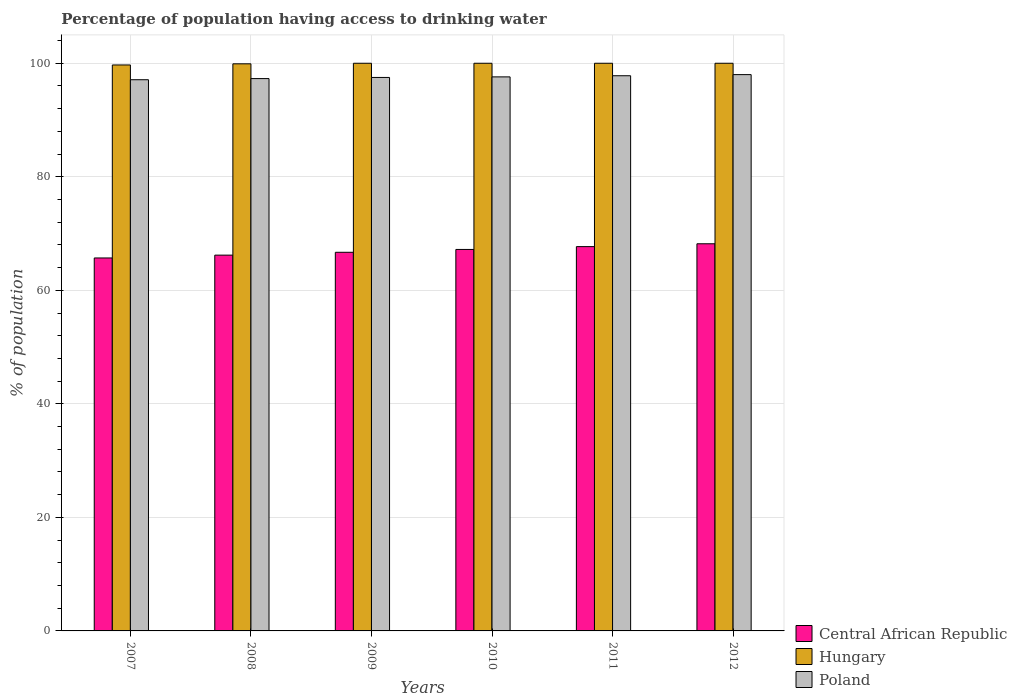How many bars are there on the 6th tick from the right?
Provide a short and direct response. 3. What is the label of the 4th group of bars from the left?
Give a very brief answer. 2010. In how many cases, is the number of bars for a given year not equal to the number of legend labels?
Ensure brevity in your answer.  0. What is the percentage of population having access to drinking water in Hungary in 2007?
Your answer should be very brief. 99.7. Across all years, what is the maximum percentage of population having access to drinking water in Central African Republic?
Provide a succinct answer. 68.2. Across all years, what is the minimum percentage of population having access to drinking water in Poland?
Ensure brevity in your answer.  97.1. In which year was the percentage of population having access to drinking water in Central African Republic maximum?
Provide a short and direct response. 2012. What is the total percentage of population having access to drinking water in Hungary in the graph?
Your answer should be very brief. 599.6. What is the difference between the percentage of population having access to drinking water in Central African Republic in 2010 and that in 2012?
Your answer should be compact. -1. What is the difference between the percentage of population having access to drinking water in Hungary in 2011 and the percentage of population having access to drinking water in Central African Republic in 2010?
Provide a short and direct response. 32.8. What is the average percentage of population having access to drinking water in Poland per year?
Your answer should be compact. 97.55. In the year 2008, what is the difference between the percentage of population having access to drinking water in Hungary and percentage of population having access to drinking water in Central African Republic?
Offer a terse response. 33.7. In how many years, is the percentage of population having access to drinking water in Poland greater than 64 %?
Provide a short and direct response. 6. What is the ratio of the percentage of population having access to drinking water in Poland in 2010 to that in 2011?
Offer a very short reply. 1. Is the percentage of population having access to drinking water in Central African Republic in 2007 less than that in 2010?
Provide a succinct answer. Yes. What is the difference between the highest and the second highest percentage of population having access to drinking water in Central African Republic?
Provide a succinct answer. 0.5. What is the difference between the highest and the lowest percentage of population having access to drinking water in Poland?
Your response must be concise. 0.9. Is the sum of the percentage of population having access to drinking water in Poland in 2008 and 2009 greater than the maximum percentage of population having access to drinking water in Hungary across all years?
Make the answer very short. Yes. What does the 3rd bar from the left in 2010 represents?
Provide a succinct answer. Poland. Is it the case that in every year, the sum of the percentage of population having access to drinking water in Hungary and percentage of population having access to drinking water in Poland is greater than the percentage of population having access to drinking water in Central African Republic?
Your answer should be compact. Yes. How many bars are there?
Provide a succinct answer. 18. How many years are there in the graph?
Your response must be concise. 6. Are the values on the major ticks of Y-axis written in scientific E-notation?
Provide a succinct answer. No. What is the title of the graph?
Provide a short and direct response. Percentage of population having access to drinking water. Does "Other small states" appear as one of the legend labels in the graph?
Your response must be concise. No. What is the label or title of the Y-axis?
Ensure brevity in your answer.  % of population. What is the % of population of Central African Republic in 2007?
Provide a succinct answer. 65.7. What is the % of population of Hungary in 2007?
Your answer should be compact. 99.7. What is the % of population in Poland in 2007?
Offer a very short reply. 97.1. What is the % of population of Central African Republic in 2008?
Your answer should be very brief. 66.2. What is the % of population of Hungary in 2008?
Provide a short and direct response. 99.9. What is the % of population of Poland in 2008?
Your answer should be compact. 97.3. What is the % of population of Central African Republic in 2009?
Keep it short and to the point. 66.7. What is the % of population in Hungary in 2009?
Provide a succinct answer. 100. What is the % of population in Poland in 2009?
Your response must be concise. 97.5. What is the % of population in Central African Republic in 2010?
Your answer should be compact. 67.2. What is the % of population in Poland in 2010?
Provide a short and direct response. 97.6. What is the % of population in Central African Republic in 2011?
Give a very brief answer. 67.7. What is the % of population in Poland in 2011?
Offer a very short reply. 97.8. What is the % of population of Central African Republic in 2012?
Ensure brevity in your answer.  68.2. What is the % of population in Hungary in 2012?
Your answer should be compact. 100. What is the % of population of Poland in 2012?
Keep it short and to the point. 98. Across all years, what is the maximum % of population in Central African Republic?
Make the answer very short. 68.2. Across all years, what is the maximum % of population in Poland?
Your answer should be very brief. 98. Across all years, what is the minimum % of population of Central African Republic?
Make the answer very short. 65.7. Across all years, what is the minimum % of population in Hungary?
Make the answer very short. 99.7. Across all years, what is the minimum % of population in Poland?
Offer a very short reply. 97.1. What is the total % of population of Central African Republic in the graph?
Provide a short and direct response. 401.7. What is the total % of population of Hungary in the graph?
Provide a short and direct response. 599.6. What is the total % of population of Poland in the graph?
Your response must be concise. 585.3. What is the difference between the % of population in Central African Republic in 2007 and that in 2008?
Provide a succinct answer. -0.5. What is the difference between the % of population of Central African Republic in 2007 and that in 2009?
Keep it short and to the point. -1. What is the difference between the % of population of Hungary in 2007 and that in 2009?
Provide a succinct answer. -0.3. What is the difference between the % of population of Poland in 2007 and that in 2010?
Your response must be concise. -0.5. What is the difference between the % of population of Hungary in 2007 and that in 2011?
Provide a short and direct response. -0.3. What is the difference between the % of population of Poland in 2007 and that in 2011?
Your answer should be very brief. -0.7. What is the difference between the % of population in Central African Republic in 2007 and that in 2012?
Your answer should be compact. -2.5. What is the difference between the % of population in Hungary in 2007 and that in 2012?
Make the answer very short. -0.3. What is the difference between the % of population of Hungary in 2008 and that in 2009?
Make the answer very short. -0.1. What is the difference between the % of population of Poland in 2008 and that in 2010?
Give a very brief answer. -0.3. What is the difference between the % of population of Central African Republic in 2008 and that in 2011?
Your answer should be compact. -1.5. What is the difference between the % of population of Central African Republic in 2009 and that in 2010?
Provide a short and direct response. -0.5. What is the difference between the % of population in Hungary in 2009 and that in 2010?
Make the answer very short. 0. What is the difference between the % of population in Poland in 2009 and that in 2010?
Ensure brevity in your answer.  -0.1. What is the difference between the % of population in Central African Republic in 2009 and that in 2011?
Make the answer very short. -1. What is the difference between the % of population of Hungary in 2009 and that in 2012?
Give a very brief answer. 0. What is the difference between the % of population of Central African Republic in 2010 and that in 2011?
Your answer should be very brief. -0.5. What is the difference between the % of population of Hungary in 2010 and that in 2011?
Ensure brevity in your answer.  0. What is the difference between the % of population of Poland in 2010 and that in 2011?
Offer a terse response. -0.2. What is the difference between the % of population of Central African Republic in 2010 and that in 2012?
Your answer should be very brief. -1. What is the difference between the % of population of Poland in 2010 and that in 2012?
Provide a succinct answer. -0.4. What is the difference between the % of population of Poland in 2011 and that in 2012?
Offer a terse response. -0.2. What is the difference between the % of population of Central African Republic in 2007 and the % of population of Hungary in 2008?
Offer a terse response. -34.2. What is the difference between the % of population of Central African Republic in 2007 and the % of population of Poland in 2008?
Keep it short and to the point. -31.6. What is the difference between the % of population in Central African Republic in 2007 and the % of population in Hungary in 2009?
Your answer should be compact. -34.3. What is the difference between the % of population in Central African Republic in 2007 and the % of population in Poland in 2009?
Provide a short and direct response. -31.8. What is the difference between the % of population in Hungary in 2007 and the % of population in Poland in 2009?
Your answer should be very brief. 2.2. What is the difference between the % of population in Central African Republic in 2007 and the % of population in Hungary in 2010?
Offer a terse response. -34.3. What is the difference between the % of population of Central African Republic in 2007 and the % of population of Poland in 2010?
Make the answer very short. -31.9. What is the difference between the % of population in Hungary in 2007 and the % of population in Poland in 2010?
Ensure brevity in your answer.  2.1. What is the difference between the % of population in Central African Republic in 2007 and the % of population in Hungary in 2011?
Provide a succinct answer. -34.3. What is the difference between the % of population of Central African Republic in 2007 and the % of population of Poland in 2011?
Your answer should be compact. -32.1. What is the difference between the % of population in Hungary in 2007 and the % of population in Poland in 2011?
Make the answer very short. 1.9. What is the difference between the % of population of Central African Republic in 2007 and the % of population of Hungary in 2012?
Give a very brief answer. -34.3. What is the difference between the % of population of Central African Republic in 2007 and the % of population of Poland in 2012?
Your response must be concise. -32.3. What is the difference between the % of population of Central African Republic in 2008 and the % of population of Hungary in 2009?
Your response must be concise. -33.8. What is the difference between the % of population in Central African Republic in 2008 and the % of population in Poland in 2009?
Your answer should be very brief. -31.3. What is the difference between the % of population of Hungary in 2008 and the % of population of Poland in 2009?
Your answer should be very brief. 2.4. What is the difference between the % of population in Central African Republic in 2008 and the % of population in Hungary in 2010?
Your response must be concise. -33.8. What is the difference between the % of population of Central African Republic in 2008 and the % of population of Poland in 2010?
Provide a short and direct response. -31.4. What is the difference between the % of population in Central African Republic in 2008 and the % of population in Hungary in 2011?
Offer a terse response. -33.8. What is the difference between the % of population in Central African Republic in 2008 and the % of population in Poland in 2011?
Give a very brief answer. -31.6. What is the difference between the % of population of Hungary in 2008 and the % of population of Poland in 2011?
Give a very brief answer. 2.1. What is the difference between the % of population in Central African Republic in 2008 and the % of population in Hungary in 2012?
Your answer should be compact. -33.8. What is the difference between the % of population in Central African Republic in 2008 and the % of population in Poland in 2012?
Your answer should be compact. -31.8. What is the difference between the % of population in Hungary in 2008 and the % of population in Poland in 2012?
Ensure brevity in your answer.  1.9. What is the difference between the % of population in Central African Republic in 2009 and the % of population in Hungary in 2010?
Ensure brevity in your answer.  -33.3. What is the difference between the % of population in Central African Republic in 2009 and the % of population in Poland in 2010?
Give a very brief answer. -30.9. What is the difference between the % of population in Hungary in 2009 and the % of population in Poland in 2010?
Your answer should be very brief. 2.4. What is the difference between the % of population in Central African Republic in 2009 and the % of population in Hungary in 2011?
Offer a terse response. -33.3. What is the difference between the % of population of Central African Republic in 2009 and the % of population of Poland in 2011?
Your response must be concise. -31.1. What is the difference between the % of population of Central African Republic in 2009 and the % of population of Hungary in 2012?
Make the answer very short. -33.3. What is the difference between the % of population of Central African Republic in 2009 and the % of population of Poland in 2012?
Give a very brief answer. -31.3. What is the difference between the % of population in Hungary in 2009 and the % of population in Poland in 2012?
Your answer should be very brief. 2. What is the difference between the % of population in Central African Republic in 2010 and the % of population in Hungary in 2011?
Your answer should be compact. -32.8. What is the difference between the % of population of Central African Republic in 2010 and the % of population of Poland in 2011?
Provide a short and direct response. -30.6. What is the difference between the % of population in Central African Republic in 2010 and the % of population in Hungary in 2012?
Offer a terse response. -32.8. What is the difference between the % of population in Central African Republic in 2010 and the % of population in Poland in 2012?
Provide a succinct answer. -30.8. What is the difference between the % of population of Central African Republic in 2011 and the % of population of Hungary in 2012?
Ensure brevity in your answer.  -32.3. What is the difference between the % of population of Central African Republic in 2011 and the % of population of Poland in 2012?
Ensure brevity in your answer.  -30.3. What is the average % of population in Central African Republic per year?
Ensure brevity in your answer.  66.95. What is the average % of population of Hungary per year?
Ensure brevity in your answer.  99.93. What is the average % of population of Poland per year?
Offer a very short reply. 97.55. In the year 2007, what is the difference between the % of population in Central African Republic and % of population in Hungary?
Your response must be concise. -34. In the year 2007, what is the difference between the % of population of Central African Republic and % of population of Poland?
Your answer should be compact. -31.4. In the year 2008, what is the difference between the % of population of Central African Republic and % of population of Hungary?
Make the answer very short. -33.7. In the year 2008, what is the difference between the % of population in Central African Republic and % of population in Poland?
Provide a succinct answer. -31.1. In the year 2008, what is the difference between the % of population in Hungary and % of population in Poland?
Your answer should be compact. 2.6. In the year 2009, what is the difference between the % of population of Central African Republic and % of population of Hungary?
Ensure brevity in your answer.  -33.3. In the year 2009, what is the difference between the % of population of Central African Republic and % of population of Poland?
Provide a succinct answer. -30.8. In the year 2010, what is the difference between the % of population in Central African Republic and % of population in Hungary?
Offer a terse response. -32.8. In the year 2010, what is the difference between the % of population in Central African Republic and % of population in Poland?
Your answer should be compact. -30.4. In the year 2010, what is the difference between the % of population of Hungary and % of population of Poland?
Your response must be concise. 2.4. In the year 2011, what is the difference between the % of population in Central African Republic and % of population in Hungary?
Keep it short and to the point. -32.3. In the year 2011, what is the difference between the % of population in Central African Republic and % of population in Poland?
Give a very brief answer. -30.1. In the year 2012, what is the difference between the % of population of Central African Republic and % of population of Hungary?
Keep it short and to the point. -31.8. In the year 2012, what is the difference between the % of population in Central African Republic and % of population in Poland?
Offer a very short reply. -29.8. What is the ratio of the % of population of Central African Republic in 2007 to that in 2008?
Your answer should be very brief. 0.99. What is the ratio of the % of population in Central African Republic in 2007 to that in 2009?
Your response must be concise. 0.98. What is the ratio of the % of population of Poland in 2007 to that in 2009?
Provide a succinct answer. 1. What is the ratio of the % of population of Central African Republic in 2007 to that in 2010?
Provide a short and direct response. 0.98. What is the ratio of the % of population of Poland in 2007 to that in 2010?
Your response must be concise. 0.99. What is the ratio of the % of population in Central African Republic in 2007 to that in 2011?
Offer a terse response. 0.97. What is the ratio of the % of population of Poland in 2007 to that in 2011?
Provide a short and direct response. 0.99. What is the ratio of the % of population of Central African Republic in 2007 to that in 2012?
Give a very brief answer. 0.96. What is the ratio of the % of population of Hungary in 2007 to that in 2012?
Offer a terse response. 1. What is the ratio of the % of population of Poland in 2007 to that in 2012?
Offer a terse response. 0.99. What is the ratio of the % of population of Central African Republic in 2008 to that in 2009?
Provide a succinct answer. 0.99. What is the ratio of the % of population of Poland in 2008 to that in 2009?
Offer a very short reply. 1. What is the ratio of the % of population in Central African Republic in 2008 to that in 2010?
Offer a very short reply. 0.99. What is the ratio of the % of population of Central African Republic in 2008 to that in 2011?
Your answer should be compact. 0.98. What is the ratio of the % of population in Hungary in 2008 to that in 2011?
Give a very brief answer. 1. What is the ratio of the % of population in Central African Republic in 2008 to that in 2012?
Ensure brevity in your answer.  0.97. What is the ratio of the % of population in Poland in 2008 to that in 2012?
Provide a short and direct response. 0.99. What is the ratio of the % of population of Hungary in 2009 to that in 2010?
Make the answer very short. 1. What is the ratio of the % of population in Central African Republic in 2009 to that in 2011?
Offer a very short reply. 0.99. What is the ratio of the % of population of Hungary in 2009 to that in 2011?
Keep it short and to the point. 1. What is the ratio of the % of population in Central African Republic in 2009 to that in 2012?
Give a very brief answer. 0.98. What is the ratio of the % of population in Hungary in 2009 to that in 2012?
Your answer should be very brief. 1. What is the ratio of the % of population of Central African Republic in 2010 to that in 2011?
Keep it short and to the point. 0.99. What is the ratio of the % of population in Poland in 2010 to that in 2011?
Your answer should be very brief. 1. What is the ratio of the % of population in Central African Republic in 2010 to that in 2012?
Your answer should be compact. 0.99. What is the ratio of the % of population of Poland in 2010 to that in 2012?
Offer a terse response. 1. What is the ratio of the % of population in Central African Republic in 2011 to that in 2012?
Give a very brief answer. 0.99. What is the ratio of the % of population in Hungary in 2011 to that in 2012?
Offer a very short reply. 1. What is the difference between the highest and the second highest % of population in Hungary?
Your response must be concise. 0. 